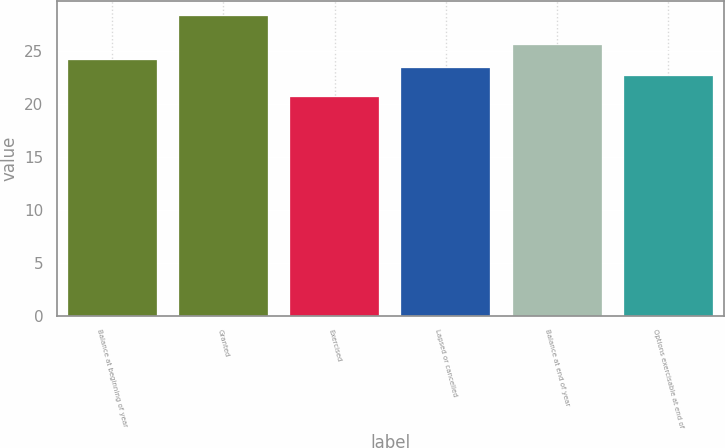Convert chart to OTSL. <chart><loc_0><loc_0><loc_500><loc_500><bar_chart><fcel>Balance at beginning of year<fcel>Granted<fcel>Exercised<fcel>Lapsed or cancelled<fcel>Balance at end of year<fcel>Options exercisable at end of<nl><fcel>24.14<fcel>28.25<fcel>20.64<fcel>23.38<fcel>25.49<fcel>22.62<nl></chart> 